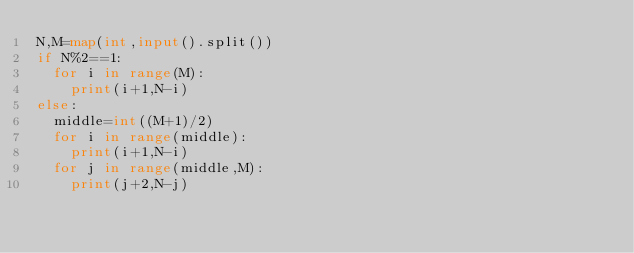<code> <loc_0><loc_0><loc_500><loc_500><_Python_>N,M=map(int,input().split())
if N%2==1:
  for i in range(M):
    print(i+1,N-i)
else:
  middle=int((M+1)/2)
  for i in range(middle):
    print(i+1,N-i)
  for j in range(middle,M):
    print(j+2,N-j)</code> 